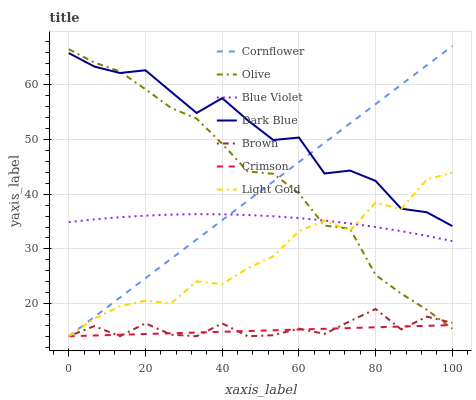Does Crimson have the minimum area under the curve?
Answer yes or no. Yes. Does Dark Blue have the maximum area under the curve?
Answer yes or no. Yes. Does Brown have the minimum area under the curve?
Answer yes or no. No. Does Brown have the maximum area under the curve?
Answer yes or no. No. Is Crimson the smoothest?
Answer yes or no. Yes. Is Dark Blue the roughest?
Answer yes or no. Yes. Is Brown the smoothest?
Answer yes or no. No. Is Brown the roughest?
Answer yes or no. No. Does Cornflower have the lowest value?
Answer yes or no. Yes. Does Dark Blue have the lowest value?
Answer yes or no. No. Does Cornflower have the highest value?
Answer yes or no. Yes. Does Brown have the highest value?
Answer yes or no. No. Is Blue Violet less than Dark Blue?
Answer yes or no. Yes. Is Blue Violet greater than Crimson?
Answer yes or no. Yes. Does Crimson intersect Brown?
Answer yes or no. Yes. Is Crimson less than Brown?
Answer yes or no. No. Is Crimson greater than Brown?
Answer yes or no. No. Does Blue Violet intersect Dark Blue?
Answer yes or no. No. 